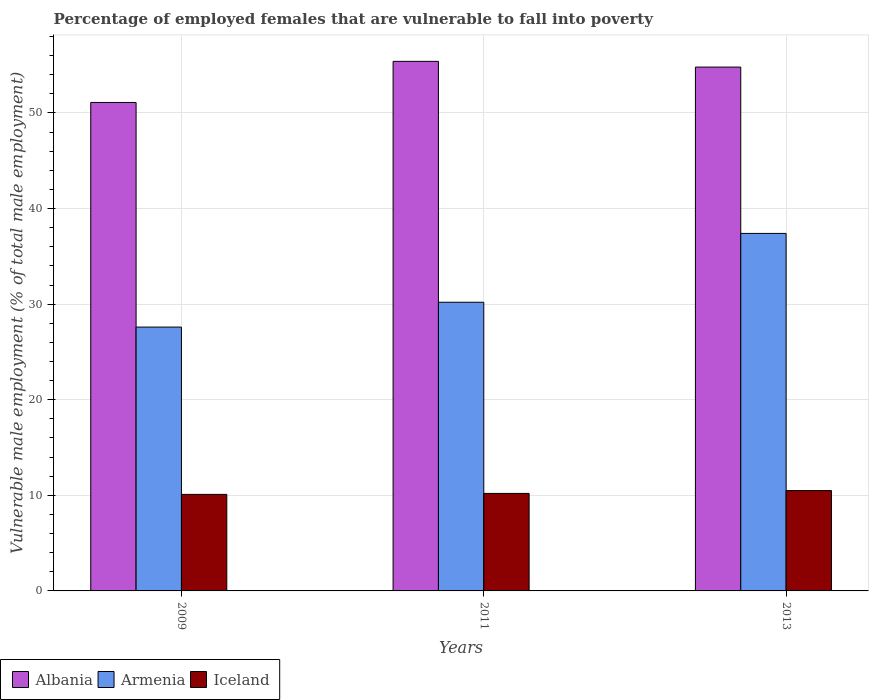How many groups of bars are there?
Offer a very short reply. 3. Are the number of bars per tick equal to the number of legend labels?
Keep it short and to the point. Yes. Are the number of bars on each tick of the X-axis equal?
Ensure brevity in your answer.  Yes. How many bars are there on the 3rd tick from the left?
Your response must be concise. 3. What is the percentage of employed females who are vulnerable to fall into poverty in Iceland in 2013?
Offer a very short reply. 10.5. Across all years, what is the maximum percentage of employed females who are vulnerable to fall into poverty in Armenia?
Keep it short and to the point. 37.4. Across all years, what is the minimum percentage of employed females who are vulnerable to fall into poverty in Armenia?
Provide a succinct answer. 27.6. In which year was the percentage of employed females who are vulnerable to fall into poverty in Albania maximum?
Keep it short and to the point. 2011. What is the total percentage of employed females who are vulnerable to fall into poverty in Iceland in the graph?
Your answer should be very brief. 30.8. What is the difference between the percentage of employed females who are vulnerable to fall into poverty in Iceland in 2011 and that in 2013?
Make the answer very short. -0.3. What is the difference between the percentage of employed females who are vulnerable to fall into poverty in Armenia in 2009 and the percentage of employed females who are vulnerable to fall into poverty in Iceland in 2013?
Provide a succinct answer. 17.1. What is the average percentage of employed females who are vulnerable to fall into poverty in Albania per year?
Ensure brevity in your answer.  53.77. In the year 2011, what is the difference between the percentage of employed females who are vulnerable to fall into poverty in Iceland and percentage of employed females who are vulnerable to fall into poverty in Albania?
Your response must be concise. -45.2. In how many years, is the percentage of employed females who are vulnerable to fall into poverty in Iceland greater than 16 %?
Provide a short and direct response. 0. What is the ratio of the percentage of employed females who are vulnerable to fall into poverty in Iceland in 2011 to that in 2013?
Keep it short and to the point. 0.97. Is the percentage of employed females who are vulnerable to fall into poverty in Iceland in 2009 less than that in 2013?
Offer a very short reply. Yes. What is the difference between the highest and the second highest percentage of employed females who are vulnerable to fall into poverty in Iceland?
Give a very brief answer. 0.3. What is the difference between the highest and the lowest percentage of employed females who are vulnerable to fall into poverty in Armenia?
Offer a very short reply. 9.8. In how many years, is the percentage of employed females who are vulnerable to fall into poverty in Iceland greater than the average percentage of employed females who are vulnerable to fall into poverty in Iceland taken over all years?
Give a very brief answer. 1. Is the sum of the percentage of employed females who are vulnerable to fall into poverty in Armenia in 2009 and 2011 greater than the maximum percentage of employed females who are vulnerable to fall into poverty in Albania across all years?
Your response must be concise. Yes. What does the 2nd bar from the left in 2009 represents?
Make the answer very short. Armenia. How many bars are there?
Make the answer very short. 9. How are the legend labels stacked?
Provide a short and direct response. Horizontal. What is the title of the graph?
Keep it short and to the point. Percentage of employed females that are vulnerable to fall into poverty. Does "Vanuatu" appear as one of the legend labels in the graph?
Your answer should be very brief. No. What is the label or title of the X-axis?
Keep it short and to the point. Years. What is the label or title of the Y-axis?
Make the answer very short. Vulnerable male employment (% of total male employment). What is the Vulnerable male employment (% of total male employment) of Albania in 2009?
Provide a succinct answer. 51.1. What is the Vulnerable male employment (% of total male employment) in Armenia in 2009?
Offer a terse response. 27.6. What is the Vulnerable male employment (% of total male employment) in Iceland in 2009?
Your response must be concise. 10.1. What is the Vulnerable male employment (% of total male employment) of Albania in 2011?
Keep it short and to the point. 55.4. What is the Vulnerable male employment (% of total male employment) of Armenia in 2011?
Offer a very short reply. 30.2. What is the Vulnerable male employment (% of total male employment) of Iceland in 2011?
Provide a succinct answer. 10.2. What is the Vulnerable male employment (% of total male employment) in Albania in 2013?
Offer a terse response. 54.8. What is the Vulnerable male employment (% of total male employment) in Armenia in 2013?
Your answer should be compact. 37.4. What is the Vulnerable male employment (% of total male employment) of Iceland in 2013?
Keep it short and to the point. 10.5. Across all years, what is the maximum Vulnerable male employment (% of total male employment) of Albania?
Keep it short and to the point. 55.4. Across all years, what is the maximum Vulnerable male employment (% of total male employment) of Armenia?
Your answer should be very brief. 37.4. Across all years, what is the maximum Vulnerable male employment (% of total male employment) of Iceland?
Provide a short and direct response. 10.5. Across all years, what is the minimum Vulnerable male employment (% of total male employment) in Albania?
Offer a very short reply. 51.1. Across all years, what is the minimum Vulnerable male employment (% of total male employment) of Armenia?
Ensure brevity in your answer.  27.6. Across all years, what is the minimum Vulnerable male employment (% of total male employment) of Iceland?
Provide a succinct answer. 10.1. What is the total Vulnerable male employment (% of total male employment) in Albania in the graph?
Offer a terse response. 161.3. What is the total Vulnerable male employment (% of total male employment) of Armenia in the graph?
Give a very brief answer. 95.2. What is the total Vulnerable male employment (% of total male employment) of Iceland in the graph?
Your answer should be very brief. 30.8. What is the difference between the Vulnerable male employment (% of total male employment) in Albania in 2009 and that in 2011?
Offer a very short reply. -4.3. What is the difference between the Vulnerable male employment (% of total male employment) in Armenia in 2009 and that in 2013?
Your answer should be very brief. -9.8. What is the difference between the Vulnerable male employment (% of total male employment) of Iceland in 2009 and that in 2013?
Offer a terse response. -0.4. What is the difference between the Vulnerable male employment (% of total male employment) in Albania in 2011 and that in 2013?
Give a very brief answer. 0.6. What is the difference between the Vulnerable male employment (% of total male employment) of Armenia in 2011 and that in 2013?
Your response must be concise. -7.2. What is the difference between the Vulnerable male employment (% of total male employment) in Albania in 2009 and the Vulnerable male employment (% of total male employment) in Armenia in 2011?
Your answer should be very brief. 20.9. What is the difference between the Vulnerable male employment (% of total male employment) in Albania in 2009 and the Vulnerable male employment (% of total male employment) in Iceland in 2011?
Keep it short and to the point. 40.9. What is the difference between the Vulnerable male employment (% of total male employment) of Albania in 2009 and the Vulnerable male employment (% of total male employment) of Armenia in 2013?
Your response must be concise. 13.7. What is the difference between the Vulnerable male employment (% of total male employment) in Albania in 2009 and the Vulnerable male employment (% of total male employment) in Iceland in 2013?
Ensure brevity in your answer.  40.6. What is the difference between the Vulnerable male employment (% of total male employment) in Armenia in 2009 and the Vulnerable male employment (% of total male employment) in Iceland in 2013?
Your answer should be very brief. 17.1. What is the difference between the Vulnerable male employment (% of total male employment) in Albania in 2011 and the Vulnerable male employment (% of total male employment) in Armenia in 2013?
Your response must be concise. 18. What is the difference between the Vulnerable male employment (% of total male employment) of Albania in 2011 and the Vulnerable male employment (% of total male employment) of Iceland in 2013?
Make the answer very short. 44.9. What is the difference between the Vulnerable male employment (% of total male employment) of Armenia in 2011 and the Vulnerable male employment (% of total male employment) of Iceland in 2013?
Provide a short and direct response. 19.7. What is the average Vulnerable male employment (% of total male employment) of Albania per year?
Give a very brief answer. 53.77. What is the average Vulnerable male employment (% of total male employment) of Armenia per year?
Make the answer very short. 31.73. What is the average Vulnerable male employment (% of total male employment) in Iceland per year?
Keep it short and to the point. 10.27. In the year 2011, what is the difference between the Vulnerable male employment (% of total male employment) of Albania and Vulnerable male employment (% of total male employment) of Armenia?
Ensure brevity in your answer.  25.2. In the year 2011, what is the difference between the Vulnerable male employment (% of total male employment) of Albania and Vulnerable male employment (% of total male employment) of Iceland?
Your answer should be very brief. 45.2. In the year 2013, what is the difference between the Vulnerable male employment (% of total male employment) in Albania and Vulnerable male employment (% of total male employment) in Armenia?
Your answer should be compact. 17.4. In the year 2013, what is the difference between the Vulnerable male employment (% of total male employment) of Albania and Vulnerable male employment (% of total male employment) of Iceland?
Your answer should be compact. 44.3. In the year 2013, what is the difference between the Vulnerable male employment (% of total male employment) in Armenia and Vulnerable male employment (% of total male employment) in Iceland?
Offer a very short reply. 26.9. What is the ratio of the Vulnerable male employment (% of total male employment) of Albania in 2009 to that in 2011?
Keep it short and to the point. 0.92. What is the ratio of the Vulnerable male employment (% of total male employment) of Armenia in 2009 to that in 2011?
Keep it short and to the point. 0.91. What is the ratio of the Vulnerable male employment (% of total male employment) of Iceland in 2009 to that in 2011?
Make the answer very short. 0.99. What is the ratio of the Vulnerable male employment (% of total male employment) in Albania in 2009 to that in 2013?
Your answer should be very brief. 0.93. What is the ratio of the Vulnerable male employment (% of total male employment) of Armenia in 2009 to that in 2013?
Provide a succinct answer. 0.74. What is the ratio of the Vulnerable male employment (% of total male employment) of Iceland in 2009 to that in 2013?
Offer a very short reply. 0.96. What is the ratio of the Vulnerable male employment (% of total male employment) in Albania in 2011 to that in 2013?
Your answer should be very brief. 1.01. What is the ratio of the Vulnerable male employment (% of total male employment) in Armenia in 2011 to that in 2013?
Keep it short and to the point. 0.81. What is the ratio of the Vulnerable male employment (% of total male employment) of Iceland in 2011 to that in 2013?
Keep it short and to the point. 0.97. What is the difference between the highest and the second highest Vulnerable male employment (% of total male employment) in Albania?
Give a very brief answer. 0.6. What is the difference between the highest and the second highest Vulnerable male employment (% of total male employment) in Armenia?
Offer a very short reply. 7.2. What is the difference between the highest and the second highest Vulnerable male employment (% of total male employment) in Iceland?
Make the answer very short. 0.3. What is the difference between the highest and the lowest Vulnerable male employment (% of total male employment) in Armenia?
Make the answer very short. 9.8. 